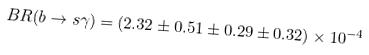<formula> <loc_0><loc_0><loc_500><loc_500>B R ( b \rightarrow s \gamma ) = ( 2 . 3 2 \pm 0 . 5 1 \pm 0 . 2 9 \pm 0 . 3 2 ) \times 1 0 ^ { - 4 }</formula> 